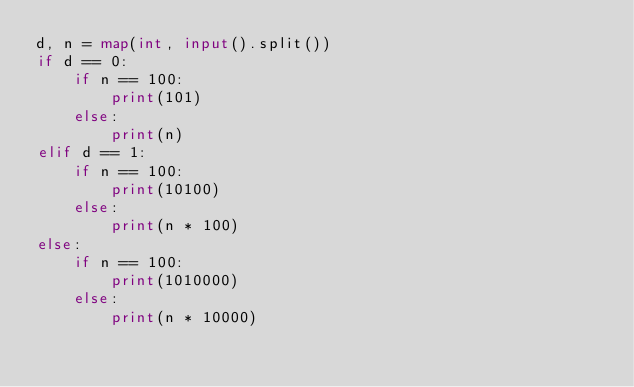Convert code to text. <code><loc_0><loc_0><loc_500><loc_500><_Python_>d, n = map(int, input().split())
if d == 0:
    if n == 100:
        print(101)
    else:
        print(n)
elif d == 1:
    if n == 100:
        print(10100)
    else:
        print(n * 100)
else:
    if n == 100:
        print(1010000)
    else:
        print(n * 10000)</code> 